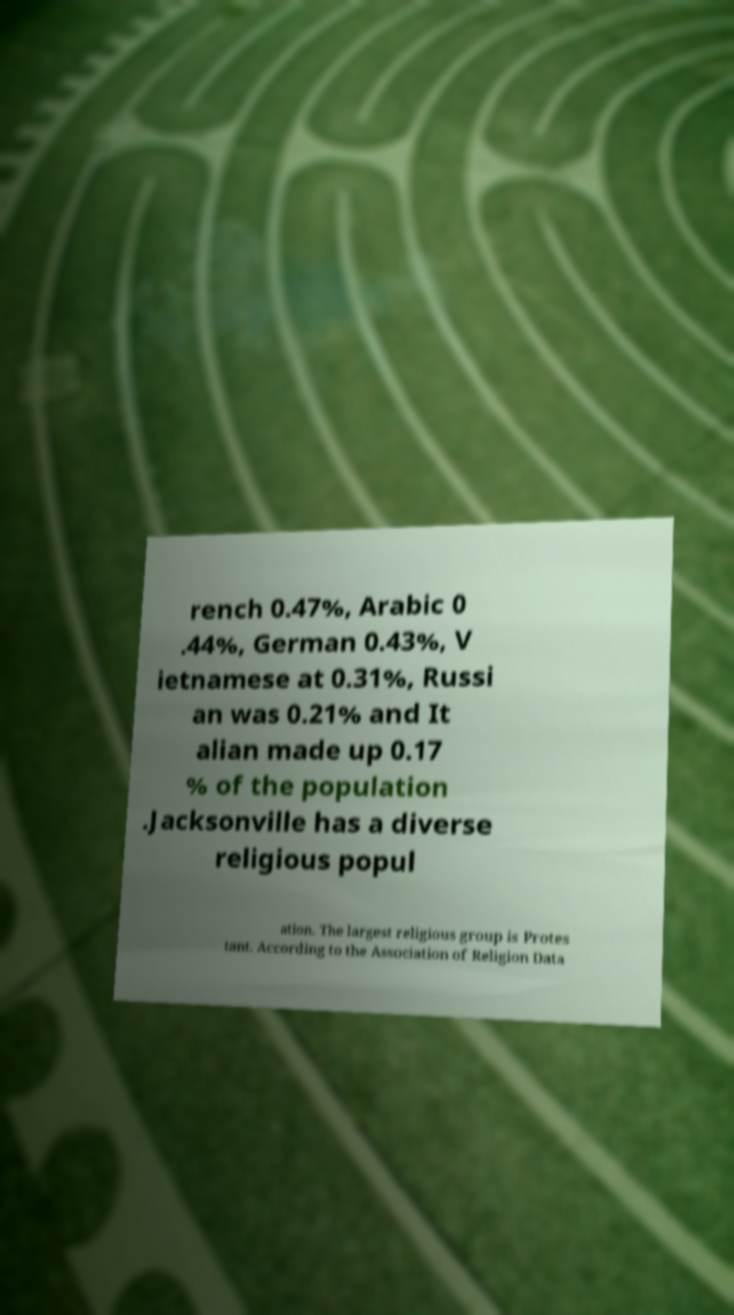Could you assist in decoding the text presented in this image and type it out clearly? rench 0.47%, Arabic 0 .44%, German 0.43%, V ietnamese at 0.31%, Russi an was 0.21% and It alian made up 0.17 % of the population .Jacksonville has a diverse religious popul ation. The largest religious group is Protes tant. According to the Association of Religion Data 